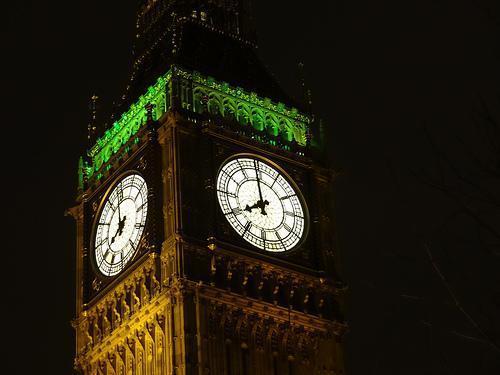How many clocks are there?
Give a very brief answer. 2. 